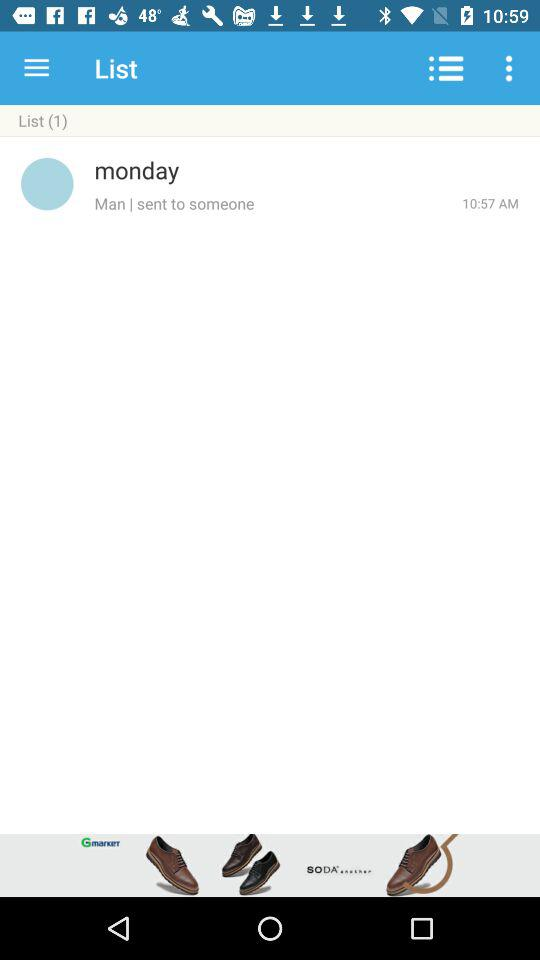How many lists are shown? There is 1 list. 